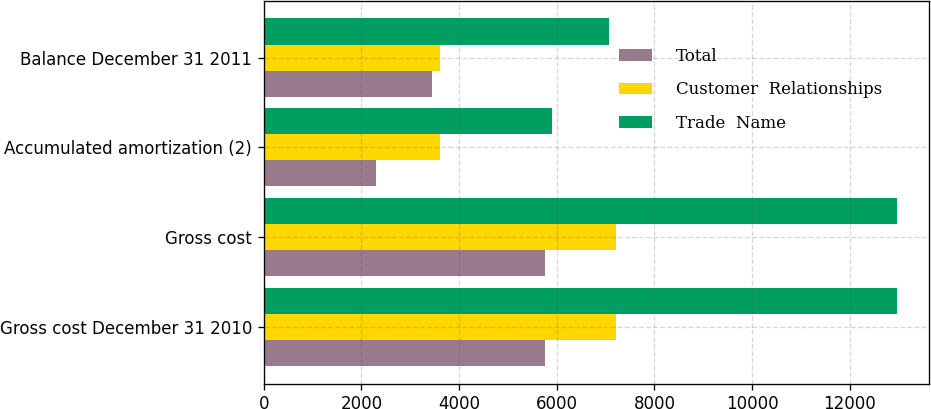Convert chart. <chart><loc_0><loc_0><loc_500><loc_500><stacked_bar_chart><ecel><fcel>Gross cost December 31 2010<fcel>Gross cost<fcel>Accumulated amortization (2)<fcel>Balance December 31 2011<nl><fcel>Total<fcel>5758<fcel>5758<fcel>2303<fcel>3455<nl><fcel>Customer  Relationships<fcel>7210<fcel>7210<fcel>3605<fcel>3605<nl><fcel>Trade  Name<fcel>12968<fcel>12968<fcel>5908<fcel>7060<nl></chart> 